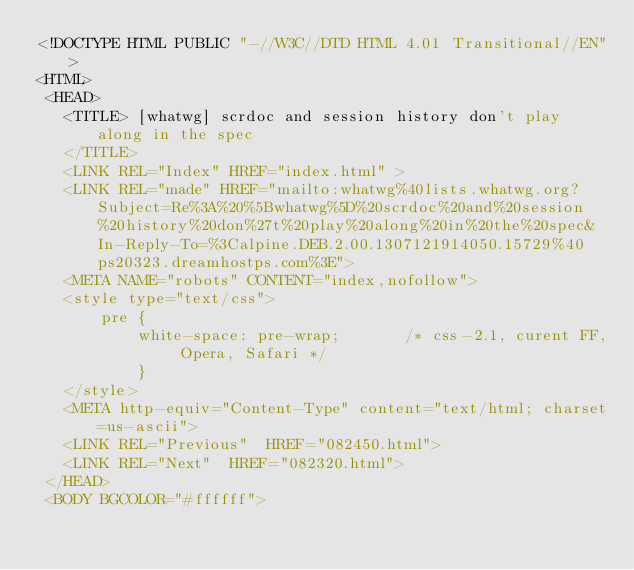<code> <loc_0><loc_0><loc_500><loc_500><_HTML_><!DOCTYPE HTML PUBLIC "-//W3C//DTD HTML 4.01 Transitional//EN">
<HTML>
 <HEAD>
   <TITLE> [whatwg] scrdoc and session history don't play along in the spec
   </TITLE>
   <LINK REL="Index" HREF="index.html" >
   <LINK REL="made" HREF="mailto:whatwg%40lists.whatwg.org?Subject=Re%3A%20%5Bwhatwg%5D%20scrdoc%20and%20session%20history%20don%27t%20play%20along%20in%20the%20spec&In-Reply-To=%3Calpine.DEB.2.00.1307121914050.15729%40ps20323.dreamhostps.com%3E">
   <META NAME="robots" CONTENT="index,nofollow">
   <style type="text/css">
       pre {
           white-space: pre-wrap;       /* css-2.1, curent FF, Opera, Safari */
           }
   </style>
   <META http-equiv="Content-Type" content="text/html; charset=us-ascii">
   <LINK REL="Previous"  HREF="082450.html">
   <LINK REL="Next"  HREF="082320.html">
 </HEAD>
 <BODY BGCOLOR="#ffffff"></code> 